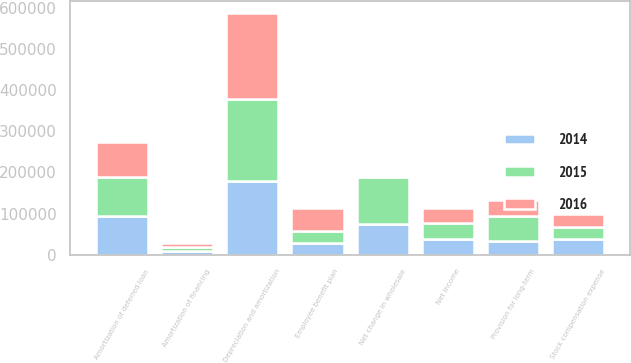Convert chart. <chart><loc_0><loc_0><loc_500><loc_500><stacked_bar_chart><ecel><fcel>Net income<fcel>Depreciation and amortization<fcel>Amortization of deferred loan<fcel>Amortization of financing<fcel>Provision for long-term<fcel>Employee benefit plan<fcel>Stock compensation expense<fcel>Net change in wholesale<nl><fcel>2016<fcel>38273<fcel>209555<fcel>86681<fcel>9252<fcel>38273<fcel>55809<fcel>32336<fcel>3233<nl><fcel>2015<fcel>38273<fcel>198074<fcel>93546<fcel>9975<fcel>60824<fcel>28490<fcel>29433<fcel>113970<nl><fcel>2014<fcel>38273<fcel>179300<fcel>94429<fcel>8442<fcel>33709<fcel>29686<fcel>37929<fcel>75210<nl></chart> 